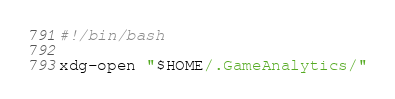<code> <loc_0><loc_0><loc_500><loc_500><_Bash_>#!/bin/bash

xdg-open "$HOME/.GameAnalytics/"
</code> 